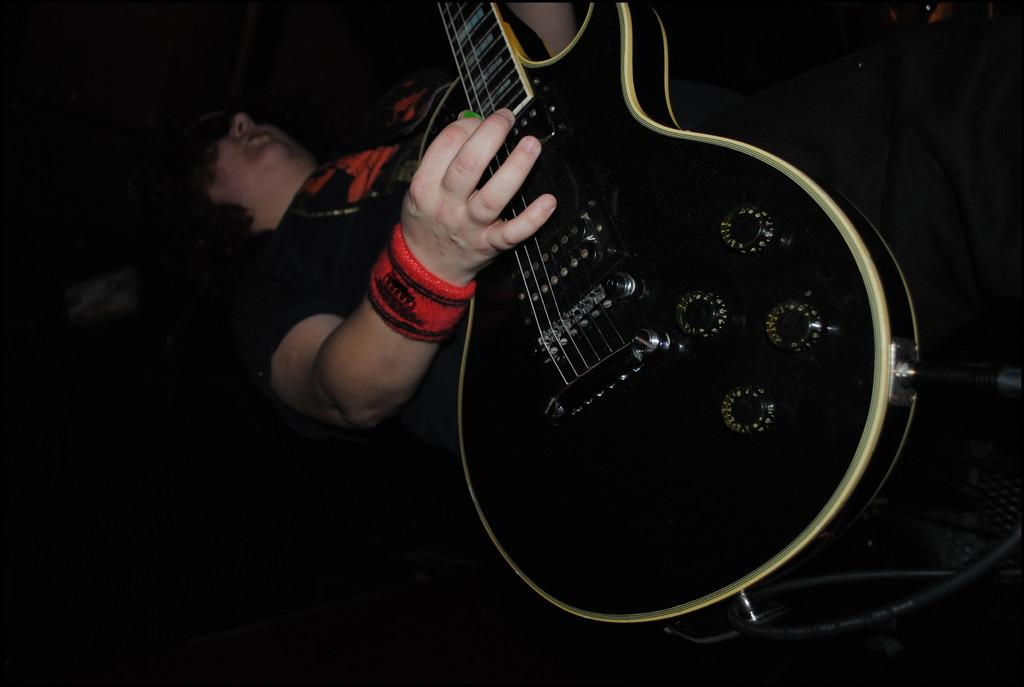What color is the t-shirt the person is wearing in the image? The person is wearing a black t-shirt. What instrument is the person playing in the image? The person is playing a black guitar. What type of peace symbol can be seen on the guitar in the image? There is no peace symbol present on the guitar in the image. How does the crack in the guitar affect the sound it produces in the image? There is no crack present on the guitar in the image. 